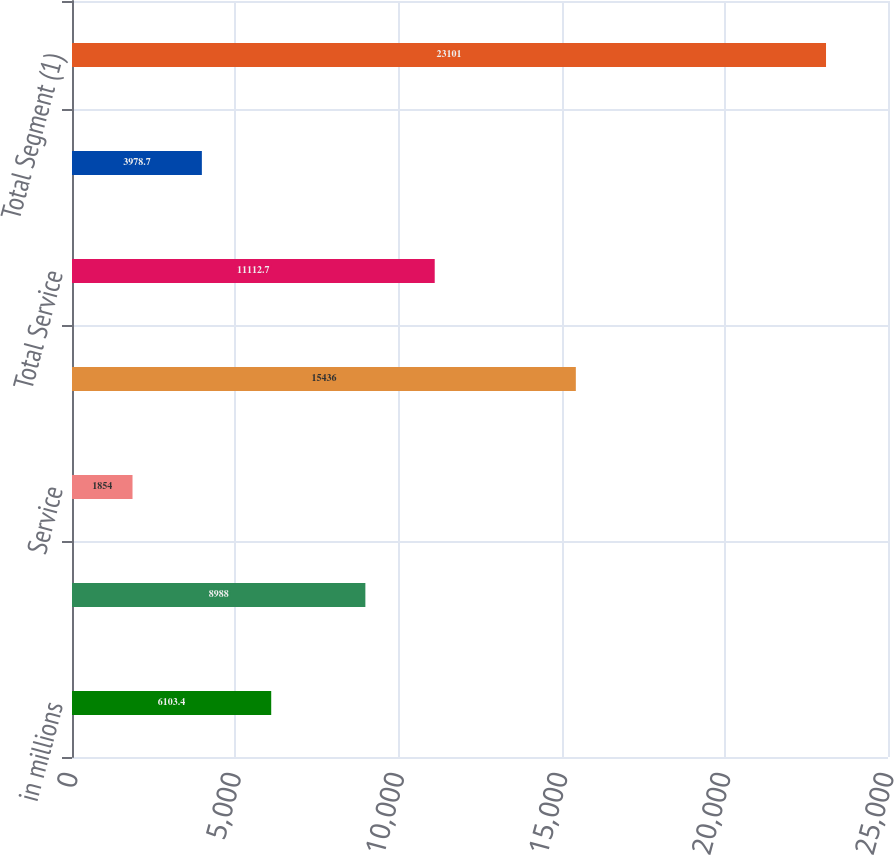<chart> <loc_0><loc_0><loc_500><loc_500><bar_chart><fcel>in millions<fcel>Product<fcel>Service<fcel>Total Product<fcel>Total Service<fcel>Intersegment eliminations<fcel>Total Segment (1)<nl><fcel>6103.4<fcel>8988<fcel>1854<fcel>15436<fcel>11112.7<fcel>3978.7<fcel>23101<nl></chart> 